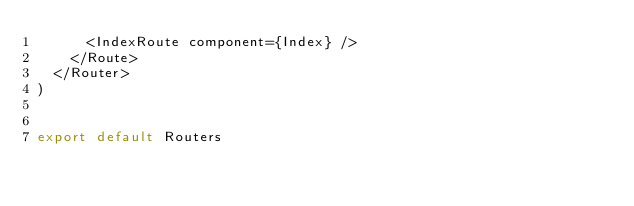Convert code to text. <code><loc_0><loc_0><loc_500><loc_500><_JavaScript_>      <IndexRoute component={Index} />
    </Route>
  </Router>
)


export default Routers
</code> 